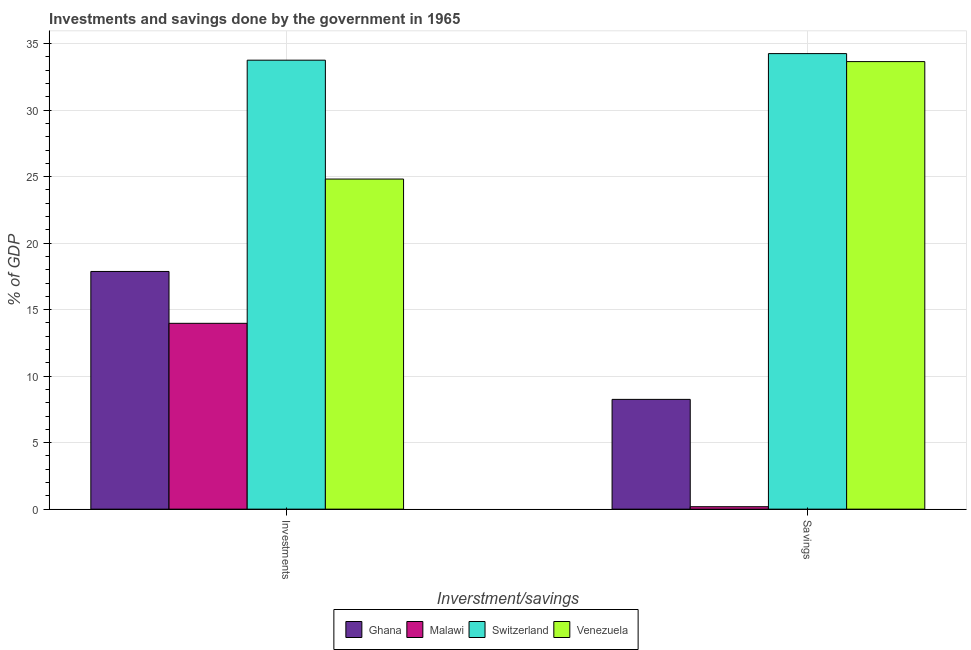Are the number of bars per tick equal to the number of legend labels?
Offer a very short reply. Yes. Are the number of bars on each tick of the X-axis equal?
Your answer should be compact. Yes. How many bars are there on the 1st tick from the right?
Your answer should be very brief. 4. What is the label of the 2nd group of bars from the left?
Ensure brevity in your answer.  Savings. What is the savings of government in Ghana?
Make the answer very short. 8.25. Across all countries, what is the maximum investments of government?
Give a very brief answer. 33.76. Across all countries, what is the minimum investments of government?
Keep it short and to the point. 13.97. In which country was the savings of government maximum?
Make the answer very short. Switzerland. In which country was the investments of government minimum?
Ensure brevity in your answer.  Malawi. What is the total investments of government in the graph?
Provide a succinct answer. 90.42. What is the difference between the investments of government in Venezuela and that in Switzerland?
Offer a terse response. -8.94. What is the difference between the savings of government in Ghana and the investments of government in Switzerland?
Your response must be concise. -25.5. What is the average investments of government per country?
Ensure brevity in your answer.  22.61. What is the difference between the investments of government and savings of government in Malawi?
Give a very brief answer. 13.79. What is the ratio of the investments of government in Ghana to that in Venezuela?
Ensure brevity in your answer.  0.72. Is the investments of government in Ghana less than that in Malawi?
Make the answer very short. No. What does the 1st bar from the left in Savings represents?
Offer a very short reply. Ghana. What does the 2nd bar from the right in Investments represents?
Provide a short and direct response. Switzerland. How many bars are there?
Give a very brief answer. 8. How many countries are there in the graph?
Keep it short and to the point. 4. What is the difference between two consecutive major ticks on the Y-axis?
Your answer should be compact. 5. Does the graph contain any zero values?
Ensure brevity in your answer.  No. Where does the legend appear in the graph?
Give a very brief answer. Bottom center. How many legend labels are there?
Give a very brief answer. 4. What is the title of the graph?
Your answer should be very brief. Investments and savings done by the government in 1965. What is the label or title of the X-axis?
Make the answer very short. Inverstment/savings. What is the label or title of the Y-axis?
Give a very brief answer. % of GDP. What is the % of GDP in Ghana in Investments?
Provide a short and direct response. 17.87. What is the % of GDP in Malawi in Investments?
Ensure brevity in your answer.  13.97. What is the % of GDP in Switzerland in Investments?
Make the answer very short. 33.76. What is the % of GDP of Venezuela in Investments?
Keep it short and to the point. 24.82. What is the % of GDP in Ghana in Savings?
Offer a very short reply. 8.25. What is the % of GDP in Malawi in Savings?
Provide a short and direct response. 0.18. What is the % of GDP of Switzerland in Savings?
Your answer should be compact. 34.25. What is the % of GDP of Venezuela in Savings?
Provide a succinct answer. 33.65. Across all Inverstment/savings, what is the maximum % of GDP in Ghana?
Make the answer very short. 17.87. Across all Inverstment/savings, what is the maximum % of GDP of Malawi?
Offer a very short reply. 13.97. Across all Inverstment/savings, what is the maximum % of GDP in Switzerland?
Make the answer very short. 34.25. Across all Inverstment/savings, what is the maximum % of GDP of Venezuela?
Your answer should be very brief. 33.65. Across all Inverstment/savings, what is the minimum % of GDP of Ghana?
Your response must be concise. 8.25. Across all Inverstment/savings, what is the minimum % of GDP of Malawi?
Your response must be concise. 0.18. Across all Inverstment/savings, what is the minimum % of GDP of Switzerland?
Provide a short and direct response. 33.76. Across all Inverstment/savings, what is the minimum % of GDP in Venezuela?
Offer a very short reply. 24.82. What is the total % of GDP of Ghana in the graph?
Make the answer very short. 26.13. What is the total % of GDP in Malawi in the graph?
Keep it short and to the point. 14.15. What is the total % of GDP of Switzerland in the graph?
Your answer should be very brief. 68.01. What is the total % of GDP of Venezuela in the graph?
Provide a succinct answer. 58.47. What is the difference between the % of GDP of Ghana in Investments and that in Savings?
Offer a very short reply. 9.62. What is the difference between the % of GDP of Malawi in Investments and that in Savings?
Provide a succinct answer. 13.79. What is the difference between the % of GDP in Switzerland in Investments and that in Savings?
Keep it short and to the point. -0.49. What is the difference between the % of GDP of Venezuela in Investments and that in Savings?
Provide a succinct answer. -8.83. What is the difference between the % of GDP in Ghana in Investments and the % of GDP in Malawi in Savings?
Make the answer very short. 17.69. What is the difference between the % of GDP of Ghana in Investments and the % of GDP of Switzerland in Savings?
Your answer should be compact. -16.38. What is the difference between the % of GDP in Ghana in Investments and the % of GDP in Venezuela in Savings?
Offer a very short reply. -15.78. What is the difference between the % of GDP of Malawi in Investments and the % of GDP of Switzerland in Savings?
Give a very brief answer. -20.28. What is the difference between the % of GDP of Malawi in Investments and the % of GDP of Venezuela in Savings?
Provide a succinct answer. -19.68. What is the difference between the % of GDP in Switzerland in Investments and the % of GDP in Venezuela in Savings?
Your answer should be compact. 0.11. What is the average % of GDP of Ghana per Inverstment/savings?
Your answer should be compact. 13.06. What is the average % of GDP in Malawi per Inverstment/savings?
Your answer should be compact. 7.08. What is the average % of GDP in Switzerland per Inverstment/savings?
Ensure brevity in your answer.  34. What is the average % of GDP of Venezuela per Inverstment/savings?
Make the answer very short. 29.23. What is the difference between the % of GDP in Ghana and % of GDP in Malawi in Investments?
Make the answer very short. 3.9. What is the difference between the % of GDP in Ghana and % of GDP in Switzerland in Investments?
Ensure brevity in your answer.  -15.89. What is the difference between the % of GDP in Ghana and % of GDP in Venezuela in Investments?
Ensure brevity in your answer.  -6.95. What is the difference between the % of GDP of Malawi and % of GDP of Switzerland in Investments?
Offer a terse response. -19.79. What is the difference between the % of GDP in Malawi and % of GDP in Venezuela in Investments?
Your response must be concise. -10.85. What is the difference between the % of GDP in Switzerland and % of GDP in Venezuela in Investments?
Give a very brief answer. 8.94. What is the difference between the % of GDP in Ghana and % of GDP in Malawi in Savings?
Your response must be concise. 8.07. What is the difference between the % of GDP of Ghana and % of GDP of Switzerland in Savings?
Keep it short and to the point. -26. What is the difference between the % of GDP of Ghana and % of GDP of Venezuela in Savings?
Provide a succinct answer. -25.4. What is the difference between the % of GDP in Malawi and % of GDP in Switzerland in Savings?
Your response must be concise. -34.07. What is the difference between the % of GDP of Malawi and % of GDP of Venezuela in Savings?
Offer a terse response. -33.47. What is the difference between the % of GDP in Switzerland and % of GDP in Venezuela in Savings?
Provide a short and direct response. 0.6. What is the ratio of the % of GDP in Ghana in Investments to that in Savings?
Your answer should be very brief. 2.17. What is the ratio of the % of GDP of Malawi in Investments to that in Savings?
Your answer should be compact. 76.33. What is the ratio of the % of GDP in Switzerland in Investments to that in Savings?
Provide a succinct answer. 0.99. What is the ratio of the % of GDP of Venezuela in Investments to that in Savings?
Your answer should be compact. 0.74. What is the difference between the highest and the second highest % of GDP in Ghana?
Your answer should be very brief. 9.62. What is the difference between the highest and the second highest % of GDP of Malawi?
Provide a short and direct response. 13.79. What is the difference between the highest and the second highest % of GDP in Switzerland?
Ensure brevity in your answer.  0.49. What is the difference between the highest and the second highest % of GDP of Venezuela?
Your answer should be compact. 8.83. What is the difference between the highest and the lowest % of GDP of Ghana?
Make the answer very short. 9.62. What is the difference between the highest and the lowest % of GDP in Malawi?
Give a very brief answer. 13.79. What is the difference between the highest and the lowest % of GDP of Switzerland?
Make the answer very short. 0.49. What is the difference between the highest and the lowest % of GDP in Venezuela?
Your answer should be compact. 8.83. 